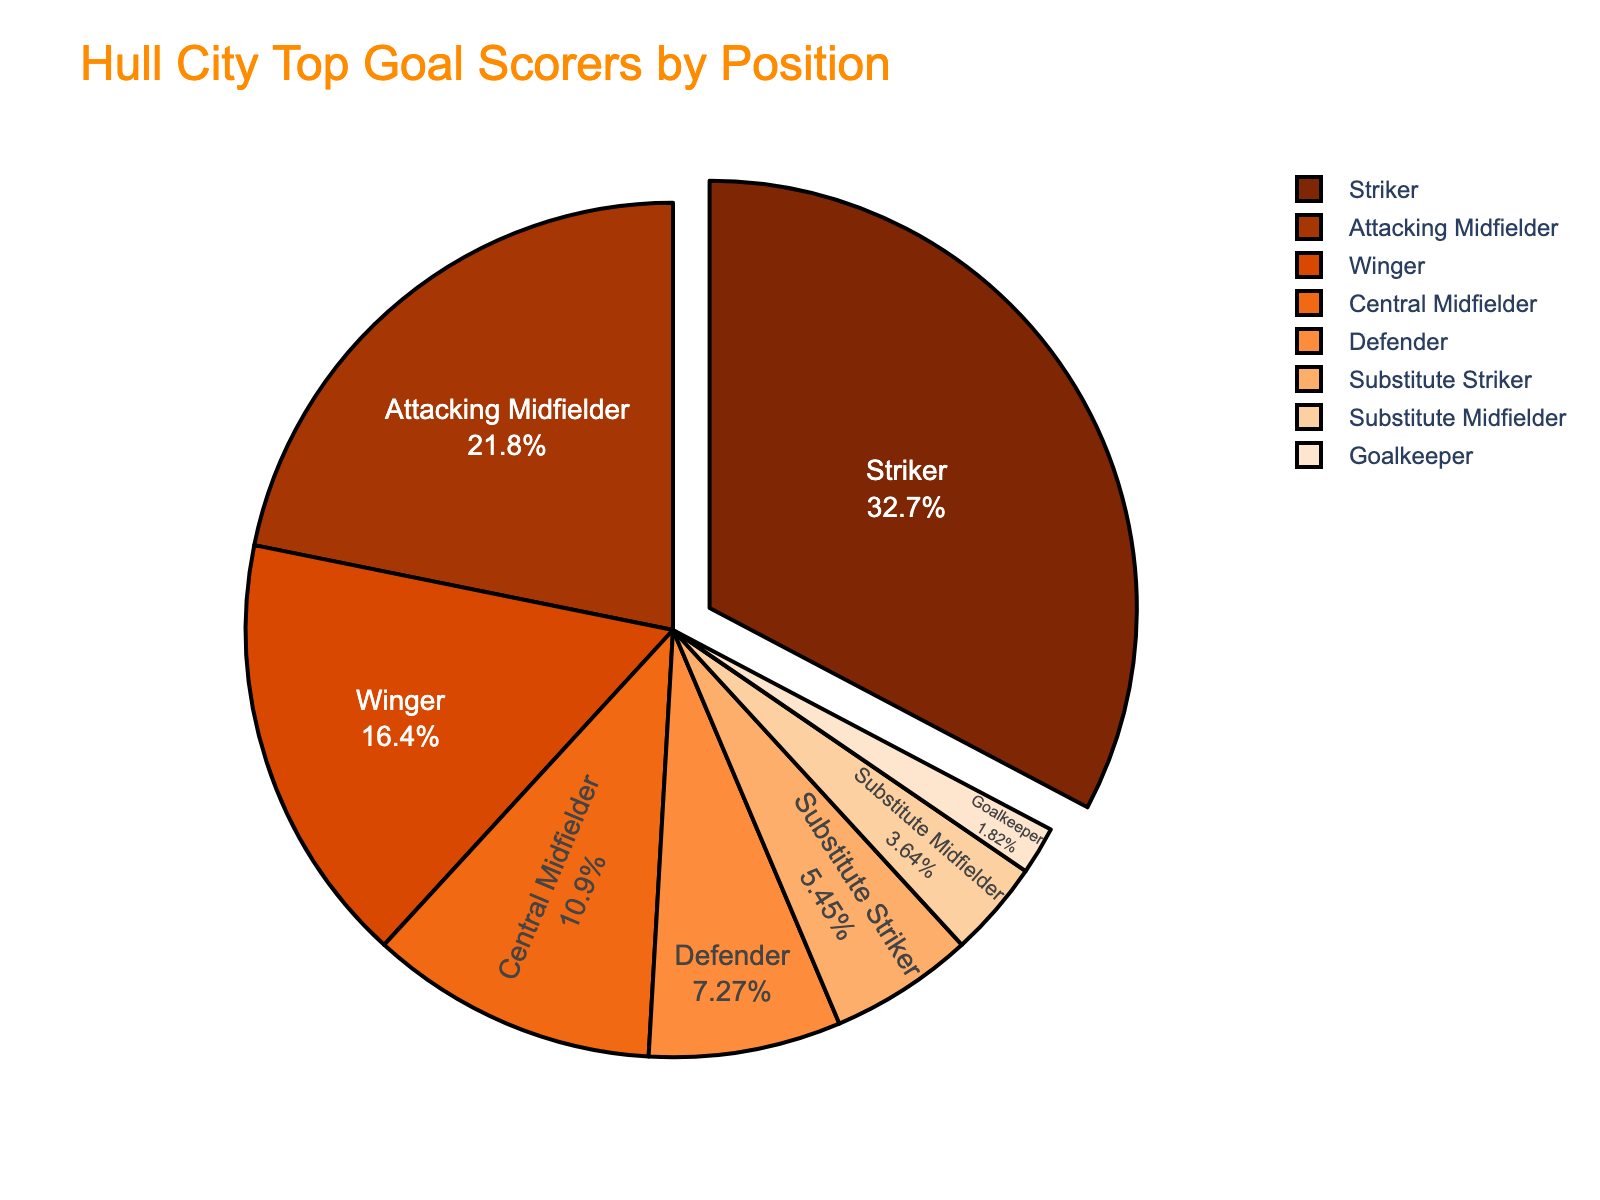Which position scored the highest number of goals? The slice that is slightly pulled out represents the highest value. The Striker has the largest slice pulled out, with 18 goals.
Answer: Striker How many more goals did the Striker score compared to the Winger? The Striker scored 18 goals, and the Winger scored 9 goals. The difference is calculated as 18 - 9.
Answer: 9 What percentage of the total goals were scored by the Attacking Midfielder? The Attacking Midfielder scored 12 goals out of the total 55 goals (18 + 12 + 9 + 6 + 4 + 3 + 2 + 1). The percentage is calculated as (12 / 55) * 100%.
Answer: Approximately 21.82% Which position scored the least number of goals, and how many did they score? The smallest slice represents the least number of goals. The Goalkeeper has the smallest slice, with 1 goal.
Answer: Goalkeeper, 1 Compare the total goals scored by all midfielders (Attacking Midfielder + Central Midfielder + Substitute Midfielder) to the total goals scored by all strikers (Striker + Substitute Striker). Which group has more goals, and by how many? The total for midfielders is (12 + 6 + 2) = 20, and the total for strikers is (18 + 3) = 21. The difference is calculated as 21 - 20.
Answer: Strikers, 1 Which position contributes the most significant portion of the pie chart? The largest slice, particularly the one slightly pulled out, is the Striker, who scored 18 goals.
Answer: Striker How many goals were scored by substitute players combined? Adding the goals scored by Substitute Striker and Substitute Midfielder: 3 + 2.
Answer: 5 What is the combined total of goals scored by the Defenders and the Goalkeeper? Adding the goals scored by Defenders and the Goalkeeper: 4 + 1.
Answer: 5 